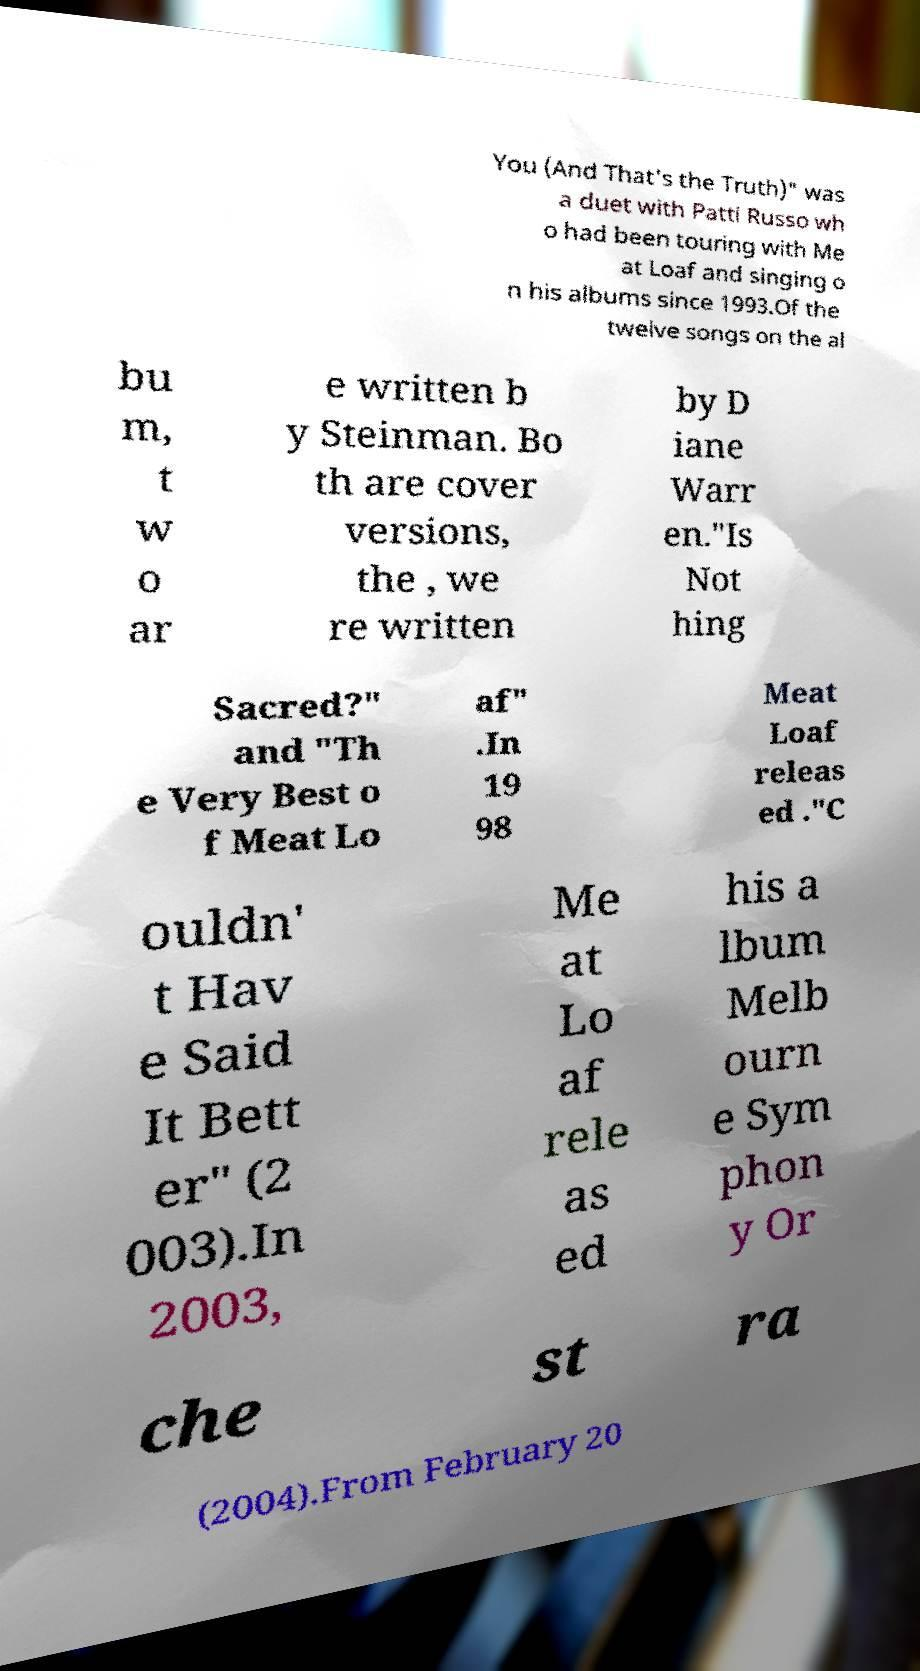There's text embedded in this image that I need extracted. Can you transcribe it verbatim? You (And That's the Truth)" was a duet with Patti Russo wh o had been touring with Me at Loaf and singing o n his albums since 1993.Of the twelve songs on the al bu m, t w o ar e written b y Steinman. Bo th are cover versions, the , we re written by D iane Warr en."Is Not hing Sacred?" and "Th e Very Best o f Meat Lo af" .In 19 98 Meat Loaf releas ed ."C ouldn' t Hav e Said It Bett er" (2 003).In 2003, Me at Lo af rele as ed his a lbum Melb ourn e Sym phon y Or che st ra (2004).From February 20 